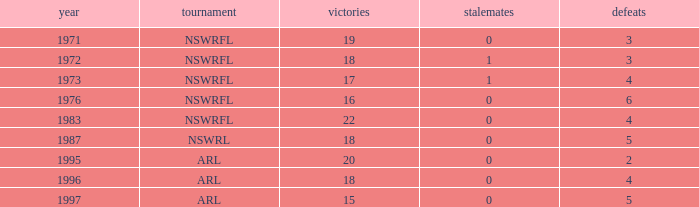What average Year has Losses 4, and Wins less than 18, and Draws greater than 1? None. 